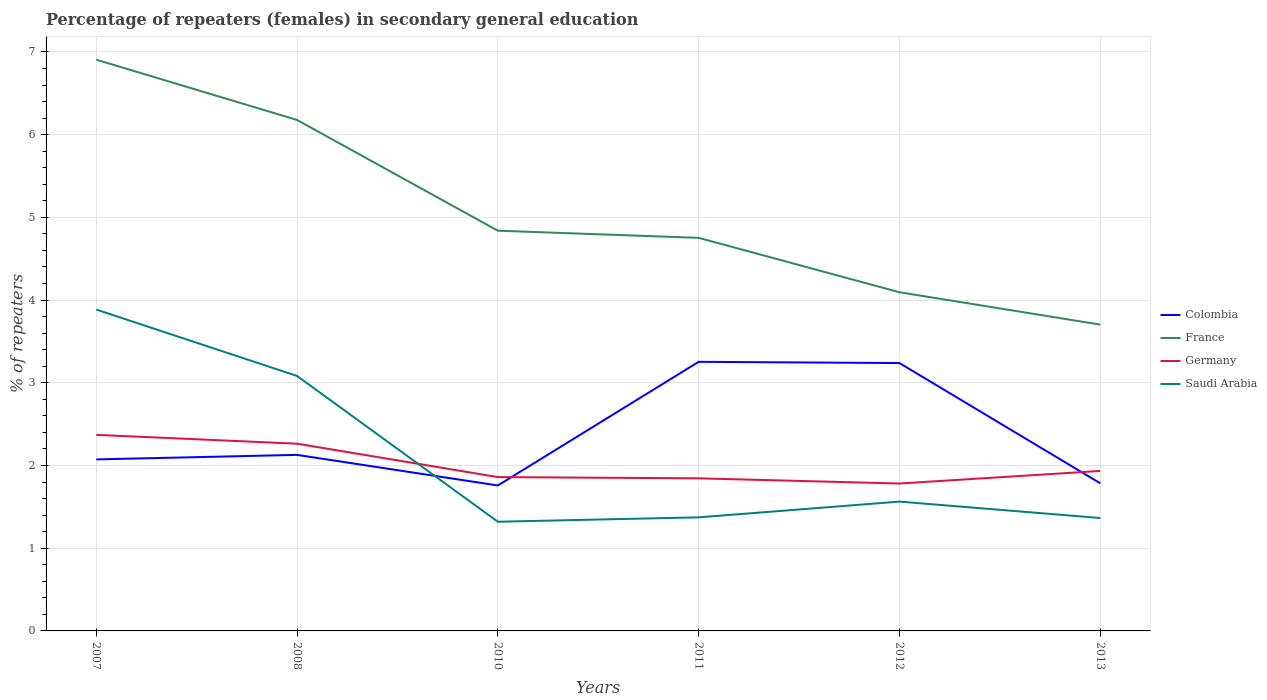Is the number of lines equal to the number of legend labels?
Provide a succinct answer. Yes. Across all years, what is the maximum percentage of female repeaters in France?
Provide a short and direct response. 3.7. What is the total percentage of female repeaters in France in the graph?
Provide a succinct answer. 0.74. What is the difference between the highest and the second highest percentage of female repeaters in Germany?
Keep it short and to the point. 0.59. How many lines are there?
Your answer should be very brief. 4. How many years are there in the graph?
Ensure brevity in your answer.  6. Does the graph contain any zero values?
Provide a short and direct response. No. Does the graph contain grids?
Offer a terse response. Yes. Where does the legend appear in the graph?
Ensure brevity in your answer.  Center right. What is the title of the graph?
Offer a very short reply. Percentage of repeaters (females) in secondary general education. Does "Spain" appear as one of the legend labels in the graph?
Your answer should be compact. No. What is the label or title of the X-axis?
Make the answer very short. Years. What is the label or title of the Y-axis?
Make the answer very short. % of repeaters. What is the % of repeaters of Colombia in 2007?
Ensure brevity in your answer.  2.07. What is the % of repeaters of France in 2007?
Offer a very short reply. 6.91. What is the % of repeaters of Germany in 2007?
Provide a short and direct response. 2.37. What is the % of repeaters in Saudi Arabia in 2007?
Ensure brevity in your answer.  3.89. What is the % of repeaters of Colombia in 2008?
Your answer should be compact. 2.13. What is the % of repeaters in France in 2008?
Provide a short and direct response. 6.18. What is the % of repeaters of Germany in 2008?
Your response must be concise. 2.26. What is the % of repeaters in Saudi Arabia in 2008?
Give a very brief answer. 3.08. What is the % of repeaters of Colombia in 2010?
Your answer should be compact. 1.76. What is the % of repeaters in France in 2010?
Ensure brevity in your answer.  4.84. What is the % of repeaters in Germany in 2010?
Offer a terse response. 1.86. What is the % of repeaters in Saudi Arabia in 2010?
Give a very brief answer. 1.32. What is the % of repeaters in Colombia in 2011?
Your answer should be very brief. 3.25. What is the % of repeaters in France in 2011?
Give a very brief answer. 4.75. What is the % of repeaters in Germany in 2011?
Your answer should be compact. 1.84. What is the % of repeaters in Saudi Arabia in 2011?
Ensure brevity in your answer.  1.37. What is the % of repeaters in Colombia in 2012?
Offer a terse response. 3.24. What is the % of repeaters of France in 2012?
Provide a short and direct response. 4.09. What is the % of repeaters in Germany in 2012?
Give a very brief answer. 1.78. What is the % of repeaters in Saudi Arabia in 2012?
Your answer should be compact. 1.56. What is the % of repeaters of Colombia in 2013?
Your answer should be compact. 1.78. What is the % of repeaters of France in 2013?
Offer a very short reply. 3.7. What is the % of repeaters in Germany in 2013?
Your answer should be very brief. 1.93. What is the % of repeaters in Saudi Arabia in 2013?
Provide a short and direct response. 1.36. Across all years, what is the maximum % of repeaters of Colombia?
Ensure brevity in your answer.  3.25. Across all years, what is the maximum % of repeaters in France?
Offer a terse response. 6.91. Across all years, what is the maximum % of repeaters of Germany?
Your response must be concise. 2.37. Across all years, what is the maximum % of repeaters in Saudi Arabia?
Give a very brief answer. 3.89. Across all years, what is the minimum % of repeaters of Colombia?
Your answer should be compact. 1.76. Across all years, what is the minimum % of repeaters in France?
Give a very brief answer. 3.7. Across all years, what is the minimum % of repeaters of Germany?
Your answer should be compact. 1.78. Across all years, what is the minimum % of repeaters of Saudi Arabia?
Ensure brevity in your answer.  1.32. What is the total % of repeaters in Colombia in the graph?
Provide a succinct answer. 14.24. What is the total % of repeaters of France in the graph?
Give a very brief answer. 30.47. What is the total % of repeaters of Germany in the graph?
Ensure brevity in your answer.  12.06. What is the total % of repeaters of Saudi Arabia in the graph?
Your answer should be compact. 12.59. What is the difference between the % of repeaters in Colombia in 2007 and that in 2008?
Ensure brevity in your answer.  -0.05. What is the difference between the % of repeaters of France in 2007 and that in 2008?
Your answer should be very brief. 0.73. What is the difference between the % of repeaters of Germany in 2007 and that in 2008?
Your answer should be compact. 0.11. What is the difference between the % of repeaters in Saudi Arabia in 2007 and that in 2008?
Offer a terse response. 0.8. What is the difference between the % of repeaters of Colombia in 2007 and that in 2010?
Keep it short and to the point. 0.32. What is the difference between the % of repeaters of France in 2007 and that in 2010?
Keep it short and to the point. 2.07. What is the difference between the % of repeaters in Germany in 2007 and that in 2010?
Provide a short and direct response. 0.51. What is the difference between the % of repeaters of Saudi Arabia in 2007 and that in 2010?
Provide a short and direct response. 2.57. What is the difference between the % of repeaters in Colombia in 2007 and that in 2011?
Provide a succinct answer. -1.18. What is the difference between the % of repeaters in France in 2007 and that in 2011?
Ensure brevity in your answer.  2.15. What is the difference between the % of repeaters of Germany in 2007 and that in 2011?
Ensure brevity in your answer.  0.53. What is the difference between the % of repeaters of Saudi Arabia in 2007 and that in 2011?
Your response must be concise. 2.51. What is the difference between the % of repeaters of Colombia in 2007 and that in 2012?
Keep it short and to the point. -1.16. What is the difference between the % of repeaters in France in 2007 and that in 2012?
Your answer should be compact. 2.81. What is the difference between the % of repeaters in Germany in 2007 and that in 2012?
Offer a very short reply. 0.59. What is the difference between the % of repeaters of Saudi Arabia in 2007 and that in 2012?
Give a very brief answer. 2.32. What is the difference between the % of repeaters of Colombia in 2007 and that in 2013?
Give a very brief answer. 0.29. What is the difference between the % of repeaters in France in 2007 and that in 2013?
Provide a succinct answer. 3.2. What is the difference between the % of repeaters of Germany in 2007 and that in 2013?
Offer a very short reply. 0.44. What is the difference between the % of repeaters in Saudi Arabia in 2007 and that in 2013?
Provide a short and direct response. 2.52. What is the difference between the % of repeaters of Colombia in 2008 and that in 2010?
Offer a terse response. 0.37. What is the difference between the % of repeaters of France in 2008 and that in 2010?
Provide a short and direct response. 1.34. What is the difference between the % of repeaters of Germany in 2008 and that in 2010?
Your answer should be very brief. 0.4. What is the difference between the % of repeaters in Saudi Arabia in 2008 and that in 2010?
Offer a terse response. 1.76. What is the difference between the % of repeaters of Colombia in 2008 and that in 2011?
Your response must be concise. -1.13. What is the difference between the % of repeaters of France in 2008 and that in 2011?
Your answer should be very brief. 1.43. What is the difference between the % of repeaters of Germany in 2008 and that in 2011?
Provide a succinct answer. 0.42. What is the difference between the % of repeaters in Saudi Arabia in 2008 and that in 2011?
Make the answer very short. 1.71. What is the difference between the % of repeaters of Colombia in 2008 and that in 2012?
Provide a short and direct response. -1.11. What is the difference between the % of repeaters of France in 2008 and that in 2012?
Provide a short and direct response. 2.08. What is the difference between the % of repeaters in Germany in 2008 and that in 2012?
Keep it short and to the point. 0.48. What is the difference between the % of repeaters in Saudi Arabia in 2008 and that in 2012?
Offer a very short reply. 1.52. What is the difference between the % of repeaters in Colombia in 2008 and that in 2013?
Offer a terse response. 0.34. What is the difference between the % of repeaters in France in 2008 and that in 2013?
Provide a succinct answer. 2.47. What is the difference between the % of repeaters in Germany in 2008 and that in 2013?
Offer a very short reply. 0.33. What is the difference between the % of repeaters of Saudi Arabia in 2008 and that in 2013?
Provide a succinct answer. 1.72. What is the difference between the % of repeaters in Colombia in 2010 and that in 2011?
Your answer should be very brief. -1.5. What is the difference between the % of repeaters of France in 2010 and that in 2011?
Provide a succinct answer. 0.09. What is the difference between the % of repeaters of Germany in 2010 and that in 2011?
Your answer should be compact. 0.02. What is the difference between the % of repeaters in Saudi Arabia in 2010 and that in 2011?
Your response must be concise. -0.05. What is the difference between the % of repeaters of Colombia in 2010 and that in 2012?
Your answer should be compact. -1.48. What is the difference between the % of repeaters in France in 2010 and that in 2012?
Your answer should be compact. 0.74. What is the difference between the % of repeaters in Germany in 2010 and that in 2012?
Make the answer very short. 0.08. What is the difference between the % of repeaters of Saudi Arabia in 2010 and that in 2012?
Provide a short and direct response. -0.24. What is the difference between the % of repeaters in Colombia in 2010 and that in 2013?
Make the answer very short. -0.03. What is the difference between the % of repeaters of France in 2010 and that in 2013?
Provide a succinct answer. 1.14. What is the difference between the % of repeaters of Germany in 2010 and that in 2013?
Make the answer very short. -0.07. What is the difference between the % of repeaters in Saudi Arabia in 2010 and that in 2013?
Offer a very short reply. -0.04. What is the difference between the % of repeaters of Colombia in 2011 and that in 2012?
Give a very brief answer. 0.01. What is the difference between the % of repeaters of France in 2011 and that in 2012?
Your answer should be very brief. 0.66. What is the difference between the % of repeaters in Germany in 2011 and that in 2012?
Provide a short and direct response. 0.06. What is the difference between the % of repeaters in Saudi Arabia in 2011 and that in 2012?
Make the answer very short. -0.19. What is the difference between the % of repeaters of Colombia in 2011 and that in 2013?
Offer a terse response. 1.47. What is the difference between the % of repeaters in France in 2011 and that in 2013?
Offer a terse response. 1.05. What is the difference between the % of repeaters in Germany in 2011 and that in 2013?
Your response must be concise. -0.09. What is the difference between the % of repeaters in Saudi Arabia in 2011 and that in 2013?
Keep it short and to the point. 0.01. What is the difference between the % of repeaters of Colombia in 2012 and that in 2013?
Offer a very short reply. 1.45. What is the difference between the % of repeaters in France in 2012 and that in 2013?
Offer a terse response. 0.39. What is the difference between the % of repeaters in Germany in 2012 and that in 2013?
Provide a succinct answer. -0.15. What is the difference between the % of repeaters of Saudi Arabia in 2012 and that in 2013?
Give a very brief answer. 0.2. What is the difference between the % of repeaters in Colombia in 2007 and the % of repeaters in France in 2008?
Your response must be concise. -4.1. What is the difference between the % of repeaters in Colombia in 2007 and the % of repeaters in Germany in 2008?
Provide a succinct answer. -0.19. What is the difference between the % of repeaters of Colombia in 2007 and the % of repeaters of Saudi Arabia in 2008?
Your answer should be very brief. -1.01. What is the difference between the % of repeaters of France in 2007 and the % of repeaters of Germany in 2008?
Ensure brevity in your answer.  4.64. What is the difference between the % of repeaters of France in 2007 and the % of repeaters of Saudi Arabia in 2008?
Your answer should be very brief. 3.82. What is the difference between the % of repeaters of Germany in 2007 and the % of repeaters of Saudi Arabia in 2008?
Offer a terse response. -0.71. What is the difference between the % of repeaters of Colombia in 2007 and the % of repeaters of France in 2010?
Your answer should be very brief. -2.77. What is the difference between the % of repeaters of Colombia in 2007 and the % of repeaters of Germany in 2010?
Ensure brevity in your answer.  0.21. What is the difference between the % of repeaters in Colombia in 2007 and the % of repeaters in Saudi Arabia in 2010?
Keep it short and to the point. 0.75. What is the difference between the % of repeaters of France in 2007 and the % of repeaters of Germany in 2010?
Make the answer very short. 5.05. What is the difference between the % of repeaters in France in 2007 and the % of repeaters in Saudi Arabia in 2010?
Your response must be concise. 5.59. What is the difference between the % of repeaters in Germany in 2007 and the % of repeaters in Saudi Arabia in 2010?
Make the answer very short. 1.05. What is the difference between the % of repeaters of Colombia in 2007 and the % of repeaters of France in 2011?
Ensure brevity in your answer.  -2.68. What is the difference between the % of repeaters of Colombia in 2007 and the % of repeaters of Germany in 2011?
Ensure brevity in your answer.  0.23. What is the difference between the % of repeaters of Colombia in 2007 and the % of repeaters of Saudi Arabia in 2011?
Make the answer very short. 0.7. What is the difference between the % of repeaters in France in 2007 and the % of repeaters in Germany in 2011?
Offer a very short reply. 5.06. What is the difference between the % of repeaters in France in 2007 and the % of repeaters in Saudi Arabia in 2011?
Offer a terse response. 5.53. What is the difference between the % of repeaters of Germany in 2007 and the % of repeaters of Saudi Arabia in 2011?
Offer a very short reply. 1. What is the difference between the % of repeaters in Colombia in 2007 and the % of repeaters in France in 2012?
Offer a very short reply. -2.02. What is the difference between the % of repeaters of Colombia in 2007 and the % of repeaters of Germany in 2012?
Offer a very short reply. 0.29. What is the difference between the % of repeaters of Colombia in 2007 and the % of repeaters of Saudi Arabia in 2012?
Your answer should be very brief. 0.51. What is the difference between the % of repeaters of France in 2007 and the % of repeaters of Germany in 2012?
Give a very brief answer. 5.12. What is the difference between the % of repeaters of France in 2007 and the % of repeaters of Saudi Arabia in 2012?
Your answer should be very brief. 5.34. What is the difference between the % of repeaters in Germany in 2007 and the % of repeaters in Saudi Arabia in 2012?
Keep it short and to the point. 0.81. What is the difference between the % of repeaters in Colombia in 2007 and the % of repeaters in France in 2013?
Offer a terse response. -1.63. What is the difference between the % of repeaters in Colombia in 2007 and the % of repeaters in Germany in 2013?
Offer a very short reply. 0.14. What is the difference between the % of repeaters of Colombia in 2007 and the % of repeaters of Saudi Arabia in 2013?
Provide a succinct answer. 0.71. What is the difference between the % of repeaters in France in 2007 and the % of repeaters in Germany in 2013?
Ensure brevity in your answer.  4.97. What is the difference between the % of repeaters in France in 2007 and the % of repeaters in Saudi Arabia in 2013?
Provide a succinct answer. 5.54. What is the difference between the % of repeaters of Germany in 2007 and the % of repeaters of Saudi Arabia in 2013?
Your answer should be compact. 1.01. What is the difference between the % of repeaters in Colombia in 2008 and the % of repeaters in France in 2010?
Provide a short and direct response. -2.71. What is the difference between the % of repeaters in Colombia in 2008 and the % of repeaters in Germany in 2010?
Your answer should be very brief. 0.27. What is the difference between the % of repeaters of Colombia in 2008 and the % of repeaters of Saudi Arabia in 2010?
Offer a very short reply. 0.81. What is the difference between the % of repeaters of France in 2008 and the % of repeaters of Germany in 2010?
Offer a very short reply. 4.32. What is the difference between the % of repeaters of France in 2008 and the % of repeaters of Saudi Arabia in 2010?
Your response must be concise. 4.86. What is the difference between the % of repeaters in Germany in 2008 and the % of repeaters in Saudi Arabia in 2010?
Provide a succinct answer. 0.94. What is the difference between the % of repeaters in Colombia in 2008 and the % of repeaters in France in 2011?
Keep it short and to the point. -2.62. What is the difference between the % of repeaters in Colombia in 2008 and the % of repeaters in Germany in 2011?
Your answer should be compact. 0.28. What is the difference between the % of repeaters of Colombia in 2008 and the % of repeaters of Saudi Arabia in 2011?
Keep it short and to the point. 0.76. What is the difference between the % of repeaters of France in 2008 and the % of repeaters of Germany in 2011?
Provide a short and direct response. 4.33. What is the difference between the % of repeaters in France in 2008 and the % of repeaters in Saudi Arabia in 2011?
Keep it short and to the point. 4.8. What is the difference between the % of repeaters of Germany in 2008 and the % of repeaters of Saudi Arabia in 2011?
Provide a short and direct response. 0.89. What is the difference between the % of repeaters in Colombia in 2008 and the % of repeaters in France in 2012?
Ensure brevity in your answer.  -1.97. What is the difference between the % of repeaters in Colombia in 2008 and the % of repeaters in Germany in 2012?
Provide a short and direct response. 0.35. What is the difference between the % of repeaters of Colombia in 2008 and the % of repeaters of Saudi Arabia in 2012?
Provide a short and direct response. 0.56. What is the difference between the % of repeaters in France in 2008 and the % of repeaters in Germany in 2012?
Provide a short and direct response. 4.4. What is the difference between the % of repeaters of France in 2008 and the % of repeaters of Saudi Arabia in 2012?
Your response must be concise. 4.61. What is the difference between the % of repeaters in Germany in 2008 and the % of repeaters in Saudi Arabia in 2012?
Your answer should be very brief. 0.7. What is the difference between the % of repeaters of Colombia in 2008 and the % of repeaters of France in 2013?
Your response must be concise. -1.57. What is the difference between the % of repeaters of Colombia in 2008 and the % of repeaters of Germany in 2013?
Keep it short and to the point. 0.19. What is the difference between the % of repeaters of Colombia in 2008 and the % of repeaters of Saudi Arabia in 2013?
Offer a very short reply. 0.76. What is the difference between the % of repeaters in France in 2008 and the % of repeaters in Germany in 2013?
Provide a short and direct response. 4.24. What is the difference between the % of repeaters of France in 2008 and the % of repeaters of Saudi Arabia in 2013?
Ensure brevity in your answer.  4.81. What is the difference between the % of repeaters of Germany in 2008 and the % of repeaters of Saudi Arabia in 2013?
Ensure brevity in your answer.  0.9. What is the difference between the % of repeaters in Colombia in 2010 and the % of repeaters in France in 2011?
Provide a short and direct response. -2.99. What is the difference between the % of repeaters in Colombia in 2010 and the % of repeaters in Germany in 2011?
Give a very brief answer. -0.09. What is the difference between the % of repeaters in Colombia in 2010 and the % of repeaters in Saudi Arabia in 2011?
Your answer should be compact. 0.39. What is the difference between the % of repeaters in France in 2010 and the % of repeaters in Germany in 2011?
Provide a short and direct response. 2.99. What is the difference between the % of repeaters in France in 2010 and the % of repeaters in Saudi Arabia in 2011?
Your answer should be compact. 3.47. What is the difference between the % of repeaters of Germany in 2010 and the % of repeaters of Saudi Arabia in 2011?
Ensure brevity in your answer.  0.49. What is the difference between the % of repeaters in Colombia in 2010 and the % of repeaters in France in 2012?
Make the answer very short. -2.34. What is the difference between the % of repeaters of Colombia in 2010 and the % of repeaters of Germany in 2012?
Your answer should be compact. -0.02. What is the difference between the % of repeaters of Colombia in 2010 and the % of repeaters of Saudi Arabia in 2012?
Provide a succinct answer. 0.19. What is the difference between the % of repeaters of France in 2010 and the % of repeaters of Germany in 2012?
Give a very brief answer. 3.06. What is the difference between the % of repeaters of France in 2010 and the % of repeaters of Saudi Arabia in 2012?
Make the answer very short. 3.28. What is the difference between the % of repeaters in Germany in 2010 and the % of repeaters in Saudi Arabia in 2012?
Ensure brevity in your answer.  0.3. What is the difference between the % of repeaters of Colombia in 2010 and the % of repeaters of France in 2013?
Ensure brevity in your answer.  -1.95. What is the difference between the % of repeaters in Colombia in 2010 and the % of repeaters in Germany in 2013?
Your answer should be very brief. -0.18. What is the difference between the % of repeaters in Colombia in 2010 and the % of repeaters in Saudi Arabia in 2013?
Provide a short and direct response. 0.39. What is the difference between the % of repeaters in France in 2010 and the % of repeaters in Germany in 2013?
Keep it short and to the point. 2.9. What is the difference between the % of repeaters of France in 2010 and the % of repeaters of Saudi Arabia in 2013?
Your answer should be very brief. 3.47. What is the difference between the % of repeaters in Germany in 2010 and the % of repeaters in Saudi Arabia in 2013?
Provide a short and direct response. 0.5. What is the difference between the % of repeaters in Colombia in 2011 and the % of repeaters in France in 2012?
Offer a terse response. -0.84. What is the difference between the % of repeaters in Colombia in 2011 and the % of repeaters in Germany in 2012?
Ensure brevity in your answer.  1.47. What is the difference between the % of repeaters of Colombia in 2011 and the % of repeaters of Saudi Arabia in 2012?
Your answer should be compact. 1.69. What is the difference between the % of repeaters of France in 2011 and the % of repeaters of Germany in 2012?
Offer a very short reply. 2.97. What is the difference between the % of repeaters of France in 2011 and the % of repeaters of Saudi Arabia in 2012?
Keep it short and to the point. 3.19. What is the difference between the % of repeaters in Germany in 2011 and the % of repeaters in Saudi Arabia in 2012?
Your answer should be very brief. 0.28. What is the difference between the % of repeaters in Colombia in 2011 and the % of repeaters in France in 2013?
Your response must be concise. -0.45. What is the difference between the % of repeaters of Colombia in 2011 and the % of repeaters of Germany in 2013?
Keep it short and to the point. 1.32. What is the difference between the % of repeaters of Colombia in 2011 and the % of repeaters of Saudi Arabia in 2013?
Offer a terse response. 1.89. What is the difference between the % of repeaters of France in 2011 and the % of repeaters of Germany in 2013?
Offer a very short reply. 2.82. What is the difference between the % of repeaters of France in 2011 and the % of repeaters of Saudi Arabia in 2013?
Offer a terse response. 3.39. What is the difference between the % of repeaters of Germany in 2011 and the % of repeaters of Saudi Arabia in 2013?
Offer a very short reply. 0.48. What is the difference between the % of repeaters of Colombia in 2012 and the % of repeaters of France in 2013?
Keep it short and to the point. -0.46. What is the difference between the % of repeaters in Colombia in 2012 and the % of repeaters in Germany in 2013?
Provide a succinct answer. 1.3. What is the difference between the % of repeaters in Colombia in 2012 and the % of repeaters in Saudi Arabia in 2013?
Make the answer very short. 1.87. What is the difference between the % of repeaters of France in 2012 and the % of repeaters of Germany in 2013?
Give a very brief answer. 2.16. What is the difference between the % of repeaters in France in 2012 and the % of repeaters in Saudi Arabia in 2013?
Offer a terse response. 2.73. What is the difference between the % of repeaters in Germany in 2012 and the % of repeaters in Saudi Arabia in 2013?
Offer a very short reply. 0.42. What is the average % of repeaters in Colombia per year?
Your response must be concise. 2.37. What is the average % of repeaters of France per year?
Provide a succinct answer. 5.08. What is the average % of repeaters of Germany per year?
Keep it short and to the point. 2.01. What is the average % of repeaters in Saudi Arabia per year?
Provide a short and direct response. 2.1. In the year 2007, what is the difference between the % of repeaters of Colombia and % of repeaters of France?
Ensure brevity in your answer.  -4.83. In the year 2007, what is the difference between the % of repeaters of Colombia and % of repeaters of Germany?
Keep it short and to the point. -0.3. In the year 2007, what is the difference between the % of repeaters of Colombia and % of repeaters of Saudi Arabia?
Offer a very short reply. -1.81. In the year 2007, what is the difference between the % of repeaters of France and % of repeaters of Germany?
Provide a succinct answer. 4.54. In the year 2007, what is the difference between the % of repeaters of France and % of repeaters of Saudi Arabia?
Your answer should be compact. 3.02. In the year 2007, what is the difference between the % of repeaters in Germany and % of repeaters in Saudi Arabia?
Keep it short and to the point. -1.51. In the year 2008, what is the difference between the % of repeaters in Colombia and % of repeaters in France?
Your answer should be compact. -4.05. In the year 2008, what is the difference between the % of repeaters of Colombia and % of repeaters of Germany?
Offer a terse response. -0.14. In the year 2008, what is the difference between the % of repeaters in Colombia and % of repeaters in Saudi Arabia?
Give a very brief answer. -0.95. In the year 2008, what is the difference between the % of repeaters in France and % of repeaters in Germany?
Your answer should be very brief. 3.91. In the year 2008, what is the difference between the % of repeaters of France and % of repeaters of Saudi Arabia?
Offer a terse response. 3.1. In the year 2008, what is the difference between the % of repeaters in Germany and % of repeaters in Saudi Arabia?
Your response must be concise. -0.82. In the year 2010, what is the difference between the % of repeaters of Colombia and % of repeaters of France?
Your answer should be very brief. -3.08. In the year 2010, what is the difference between the % of repeaters of Colombia and % of repeaters of Germany?
Make the answer very short. -0.1. In the year 2010, what is the difference between the % of repeaters in Colombia and % of repeaters in Saudi Arabia?
Make the answer very short. 0.44. In the year 2010, what is the difference between the % of repeaters of France and % of repeaters of Germany?
Offer a very short reply. 2.98. In the year 2010, what is the difference between the % of repeaters in France and % of repeaters in Saudi Arabia?
Give a very brief answer. 3.52. In the year 2010, what is the difference between the % of repeaters of Germany and % of repeaters of Saudi Arabia?
Make the answer very short. 0.54. In the year 2011, what is the difference between the % of repeaters of Colombia and % of repeaters of France?
Make the answer very short. -1.5. In the year 2011, what is the difference between the % of repeaters in Colombia and % of repeaters in Germany?
Provide a succinct answer. 1.41. In the year 2011, what is the difference between the % of repeaters in Colombia and % of repeaters in Saudi Arabia?
Provide a succinct answer. 1.88. In the year 2011, what is the difference between the % of repeaters in France and % of repeaters in Germany?
Ensure brevity in your answer.  2.91. In the year 2011, what is the difference between the % of repeaters in France and % of repeaters in Saudi Arabia?
Offer a terse response. 3.38. In the year 2011, what is the difference between the % of repeaters of Germany and % of repeaters of Saudi Arabia?
Give a very brief answer. 0.47. In the year 2012, what is the difference between the % of repeaters in Colombia and % of repeaters in France?
Ensure brevity in your answer.  -0.86. In the year 2012, what is the difference between the % of repeaters in Colombia and % of repeaters in Germany?
Offer a very short reply. 1.46. In the year 2012, what is the difference between the % of repeaters of Colombia and % of repeaters of Saudi Arabia?
Provide a succinct answer. 1.68. In the year 2012, what is the difference between the % of repeaters of France and % of repeaters of Germany?
Provide a short and direct response. 2.31. In the year 2012, what is the difference between the % of repeaters in France and % of repeaters in Saudi Arabia?
Offer a very short reply. 2.53. In the year 2012, what is the difference between the % of repeaters in Germany and % of repeaters in Saudi Arabia?
Your answer should be compact. 0.22. In the year 2013, what is the difference between the % of repeaters in Colombia and % of repeaters in France?
Make the answer very short. -1.92. In the year 2013, what is the difference between the % of repeaters in Colombia and % of repeaters in Germany?
Provide a short and direct response. -0.15. In the year 2013, what is the difference between the % of repeaters in Colombia and % of repeaters in Saudi Arabia?
Your answer should be very brief. 0.42. In the year 2013, what is the difference between the % of repeaters in France and % of repeaters in Germany?
Keep it short and to the point. 1.77. In the year 2013, what is the difference between the % of repeaters of France and % of repeaters of Saudi Arabia?
Offer a very short reply. 2.34. In the year 2013, what is the difference between the % of repeaters of Germany and % of repeaters of Saudi Arabia?
Your response must be concise. 0.57. What is the ratio of the % of repeaters in Colombia in 2007 to that in 2008?
Your response must be concise. 0.97. What is the ratio of the % of repeaters of France in 2007 to that in 2008?
Your response must be concise. 1.12. What is the ratio of the % of repeaters in Germany in 2007 to that in 2008?
Provide a succinct answer. 1.05. What is the ratio of the % of repeaters of Saudi Arabia in 2007 to that in 2008?
Your answer should be very brief. 1.26. What is the ratio of the % of repeaters of Colombia in 2007 to that in 2010?
Give a very brief answer. 1.18. What is the ratio of the % of repeaters in France in 2007 to that in 2010?
Offer a terse response. 1.43. What is the ratio of the % of repeaters in Germany in 2007 to that in 2010?
Your answer should be very brief. 1.27. What is the ratio of the % of repeaters in Saudi Arabia in 2007 to that in 2010?
Your answer should be compact. 2.94. What is the ratio of the % of repeaters of Colombia in 2007 to that in 2011?
Provide a short and direct response. 0.64. What is the ratio of the % of repeaters of France in 2007 to that in 2011?
Offer a terse response. 1.45. What is the ratio of the % of repeaters in Germany in 2007 to that in 2011?
Make the answer very short. 1.29. What is the ratio of the % of repeaters of Saudi Arabia in 2007 to that in 2011?
Provide a succinct answer. 2.83. What is the ratio of the % of repeaters of Colombia in 2007 to that in 2012?
Give a very brief answer. 0.64. What is the ratio of the % of repeaters in France in 2007 to that in 2012?
Your answer should be very brief. 1.69. What is the ratio of the % of repeaters in Germany in 2007 to that in 2012?
Your answer should be very brief. 1.33. What is the ratio of the % of repeaters in Saudi Arabia in 2007 to that in 2012?
Ensure brevity in your answer.  2.49. What is the ratio of the % of repeaters of Colombia in 2007 to that in 2013?
Give a very brief answer. 1.16. What is the ratio of the % of repeaters in France in 2007 to that in 2013?
Give a very brief answer. 1.86. What is the ratio of the % of repeaters in Germany in 2007 to that in 2013?
Provide a short and direct response. 1.23. What is the ratio of the % of repeaters of Saudi Arabia in 2007 to that in 2013?
Your answer should be compact. 2.85. What is the ratio of the % of repeaters in Colombia in 2008 to that in 2010?
Your answer should be very brief. 1.21. What is the ratio of the % of repeaters in France in 2008 to that in 2010?
Your answer should be compact. 1.28. What is the ratio of the % of repeaters in Germany in 2008 to that in 2010?
Give a very brief answer. 1.22. What is the ratio of the % of repeaters of Saudi Arabia in 2008 to that in 2010?
Make the answer very short. 2.33. What is the ratio of the % of repeaters of Colombia in 2008 to that in 2011?
Ensure brevity in your answer.  0.65. What is the ratio of the % of repeaters of France in 2008 to that in 2011?
Give a very brief answer. 1.3. What is the ratio of the % of repeaters in Germany in 2008 to that in 2011?
Make the answer very short. 1.23. What is the ratio of the % of repeaters of Saudi Arabia in 2008 to that in 2011?
Provide a succinct answer. 2.24. What is the ratio of the % of repeaters in Colombia in 2008 to that in 2012?
Offer a terse response. 0.66. What is the ratio of the % of repeaters in France in 2008 to that in 2012?
Give a very brief answer. 1.51. What is the ratio of the % of repeaters in Germany in 2008 to that in 2012?
Offer a very short reply. 1.27. What is the ratio of the % of repeaters of Saudi Arabia in 2008 to that in 2012?
Give a very brief answer. 1.97. What is the ratio of the % of repeaters of Colombia in 2008 to that in 2013?
Offer a very short reply. 1.19. What is the ratio of the % of repeaters in France in 2008 to that in 2013?
Make the answer very short. 1.67. What is the ratio of the % of repeaters of Germany in 2008 to that in 2013?
Your response must be concise. 1.17. What is the ratio of the % of repeaters in Saudi Arabia in 2008 to that in 2013?
Your answer should be very brief. 2.26. What is the ratio of the % of repeaters of Colombia in 2010 to that in 2011?
Your answer should be very brief. 0.54. What is the ratio of the % of repeaters of France in 2010 to that in 2011?
Give a very brief answer. 1.02. What is the ratio of the % of repeaters in Germany in 2010 to that in 2011?
Provide a succinct answer. 1.01. What is the ratio of the % of repeaters in Saudi Arabia in 2010 to that in 2011?
Your answer should be compact. 0.96. What is the ratio of the % of repeaters of Colombia in 2010 to that in 2012?
Offer a terse response. 0.54. What is the ratio of the % of repeaters of France in 2010 to that in 2012?
Make the answer very short. 1.18. What is the ratio of the % of repeaters in Germany in 2010 to that in 2012?
Provide a short and direct response. 1.04. What is the ratio of the % of repeaters of Saudi Arabia in 2010 to that in 2012?
Your answer should be very brief. 0.84. What is the ratio of the % of repeaters in Colombia in 2010 to that in 2013?
Provide a short and direct response. 0.99. What is the ratio of the % of repeaters of France in 2010 to that in 2013?
Provide a succinct answer. 1.31. What is the ratio of the % of repeaters of Germany in 2010 to that in 2013?
Your response must be concise. 0.96. What is the ratio of the % of repeaters of Saudi Arabia in 2010 to that in 2013?
Ensure brevity in your answer.  0.97. What is the ratio of the % of repeaters of France in 2011 to that in 2012?
Your response must be concise. 1.16. What is the ratio of the % of repeaters of Germany in 2011 to that in 2012?
Your answer should be very brief. 1.03. What is the ratio of the % of repeaters in Saudi Arabia in 2011 to that in 2012?
Your answer should be very brief. 0.88. What is the ratio of the % of repeaters in Colombia in 2011 to that in 2013?
Ensure brevity in your answer.  1.82. What is the ratio of the % of repeaters of France in 2011 to that in 2013?
Offer a terse response. 1.28. What is the ratio of the % of repeaters in Germany in 2011 to that in 2013?
Make the answer very short. 0.95. What is the ratio of the % of repeaters in Saudi Arabia in 2011 to that in 2013?
Your response must be concise. 1.01. What is the ratio of the % of repeaters in Colombia in 2012 to that in 2013?
Ensure brevity in your answer.  1.81. What is the ratio of the % of repeaters of France in 2012 to that in 2013?
Provide a short and direct response. 1.11. What is the ratio of the % of repeaters in Germany in 2012 to that in 2013?
Offer a terse response. 0.92. What is the ratio of the % of repeaters in Saudi Arabia in 2012 to that in 2013?
Provide a succinct answer. 1.15. What is the difference between the highest and the second highest % of repeaters of Colombia?
Give a very brief answer. 0.01. What is the difference between the highest and the second highest % of repeaters of France?
Offer a very short reply. 0.73. What is the difference between the highest and the second highest % of repeaters in Germany?
Offer a very short reply. 0.11. What is the difference between the highest and the second highest % of repeaters in Saudi Arabia?
Offer a terse response. 0.8. What is the difference between the highest and the lowest % of repeaters of Colombia?
Give a very brief answer. 1.5. What is the difference between the highest and the lowest % of repeaters of France?
Your answer should be very brief. 3.2. What is the difference between the highest and the lowest % of repeaters in Germany?
Ensure brevity in your answer.  0.59. What is the difference between the highest and the lowest % of repeaters in Saudi Arabia?
Ensure brevity in your answer.  2.57. 